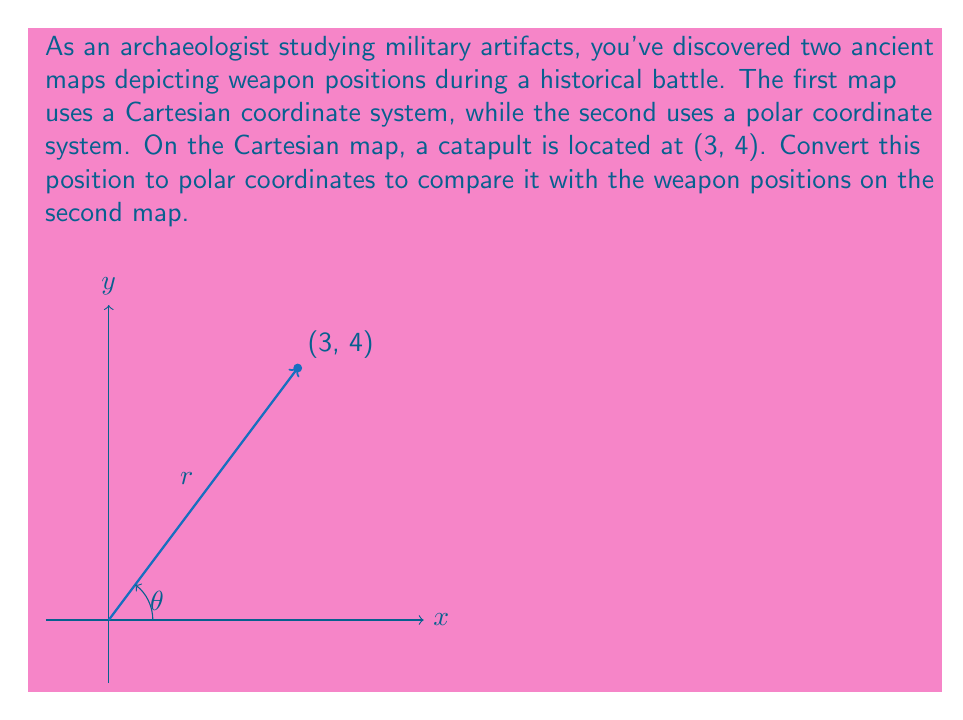Could you help me with this problem? To convert from Cartesian coordinates $(x, y)$ to polar coordinates $(r, \theta)$, we use the following formulas:

1. $r = \sqrt{x^2 + y^2}$
2. $\theta = \arctan(\frac{y}{x})$

For the catapult at (3, 4):

1. Calculate $r$:
   $$r = \sqrt{3^2 + 4^2} = \sqrt{9 + 16} = \sqrt{25} = 5$$

2. Calculate $\theta$:
   $$\theta = \arctan(\frac{4}{3}) \approx 0.9273 \text{ radians}$$

To convert radians to degrees, multiply by $\frac{180°}{\pi}$:
   $$0.9273 \times \frac{180°}{\pi} \approx 53.13°$$

Therefore, the polar coordinates of the catapult are approximately (5, 53.13°).
Answer: $(5, 53.13°)$ 